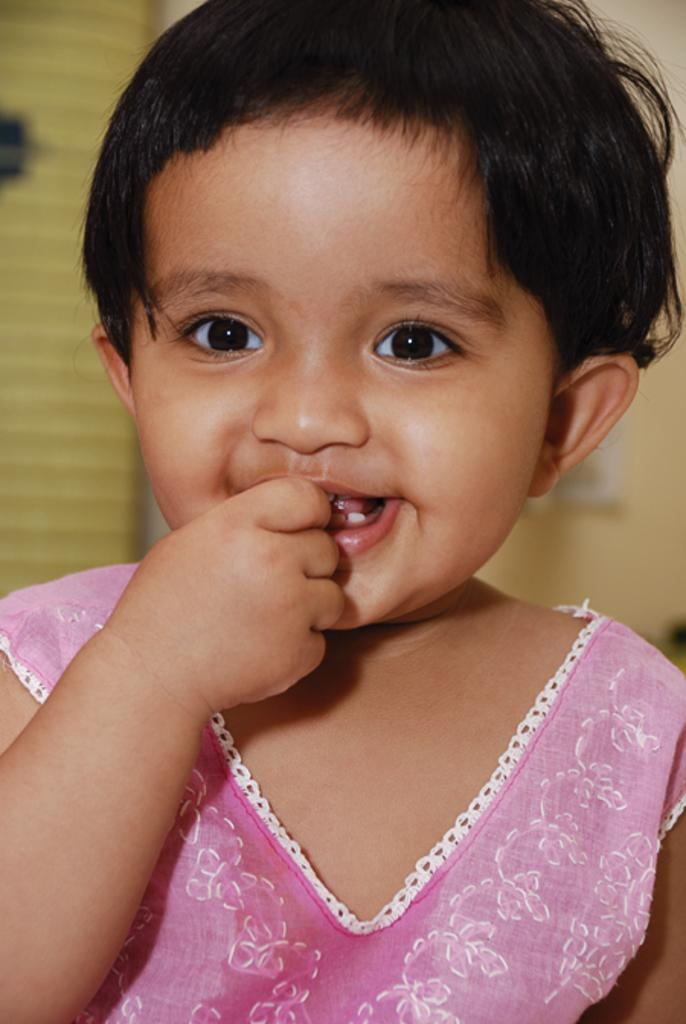What is the main subject of the image? The main subject of the image is a baby. What is the baby wearing? The baby is wearing a pink dress. What expression does the baby have? The baby is smiling. What can be seen in the background of the image? There is a wall in the background of the image. What type of fireman equipment can be seen in the image? There is no fireman equipment present in the image; it features a baby wearing a pink dress and smiling. What is the weight of the baby in the image? The weight of the baby cannot be determined from the image alone, as it does not provide any information about the baby's size or weight. 